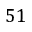Convert formula to latex. <formula><loc_0><loc_0><loc_500><loc_500>5 1</formula> 